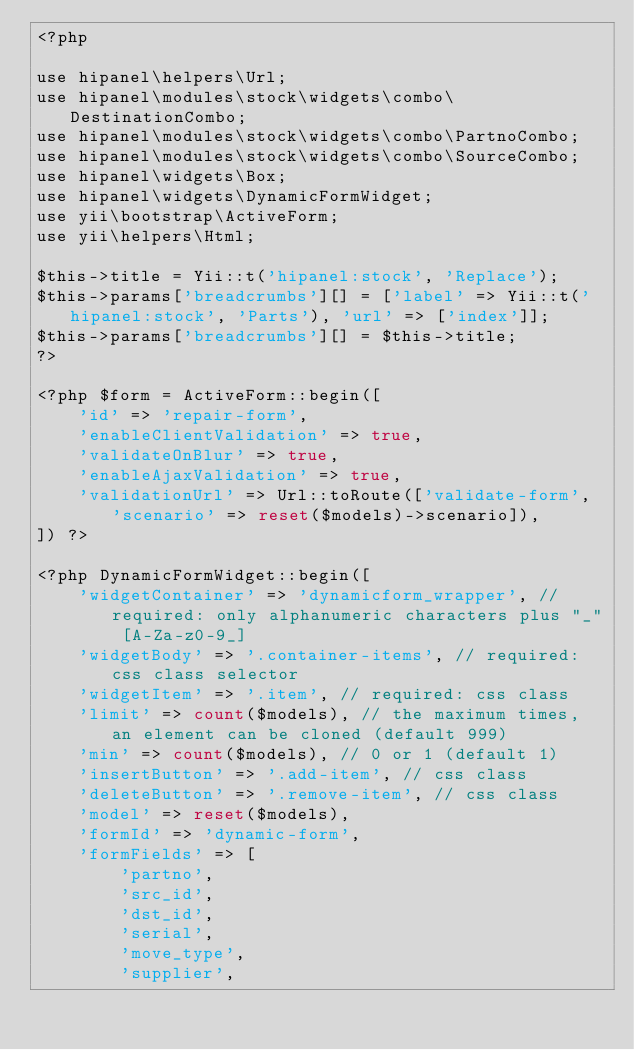Convert code to text. <code><loc_0><loc_0><loc_500><loc_500><_PHP_><?php

use hipanel\helpers\Url;
use hipanel\modules\stock\widgets\combo\DestinationCombo;
use hipanel\modules\stock\widgets\combo\PartnoCombo;
use hipanel\modules\stock\widgets\combo\SourceCombo;
use hipanel\widgets\Box;
use hipanel\widgets\DynamicFormWidget;
use yii\bootstrap\ActiveForm;
use yii\helpers\Html;

$this->title = Yii::t('hipanel:stock', 'Replace');
$this->params['breadcrumbs'][] = ['label' => Yii::t('hipanel:stock', 'Parts'), 'url' => ['index']];
$this->params['breadcrumbs'][] = $this->title;
?>

<?php $form = ActiveForm::begin([
    'id' => 'repair-form',
    'enableClientValidation' => true,
    'validateOnBlur' => true,
    'enableAjaxValidation' => true,
    'validationUrl' => Url::toRoute(['validate-form', 'scenario' => reset($models)->scenario]),
]) ?>

<?php DynamicFormWidget::begin([
    'widgetContainer' => 'dynamicform_wrapper', // required: only alphanumeric characters plus "_" [A-Za-z0-9_]
    'widgetBody' => '.container-items', // required: css class selector
    'widgetItem' => '.item', // required: css class
    'limit' => count($models), // the maximum times, an element can be cloned (default 999)
    'min' => count($models), // 0 or 1 (default 1)
    'insertButton' => '.add-item', // css class
    'deleteButton' => '.remove-item', // css class
    'model' => reset($models),
    'formId' => 'dynamic-form',
    'formFields' => [
        'partno',
        'src_id',
        'dst_id',
        'serial',
        'move_type',
        'supplier',</code> 